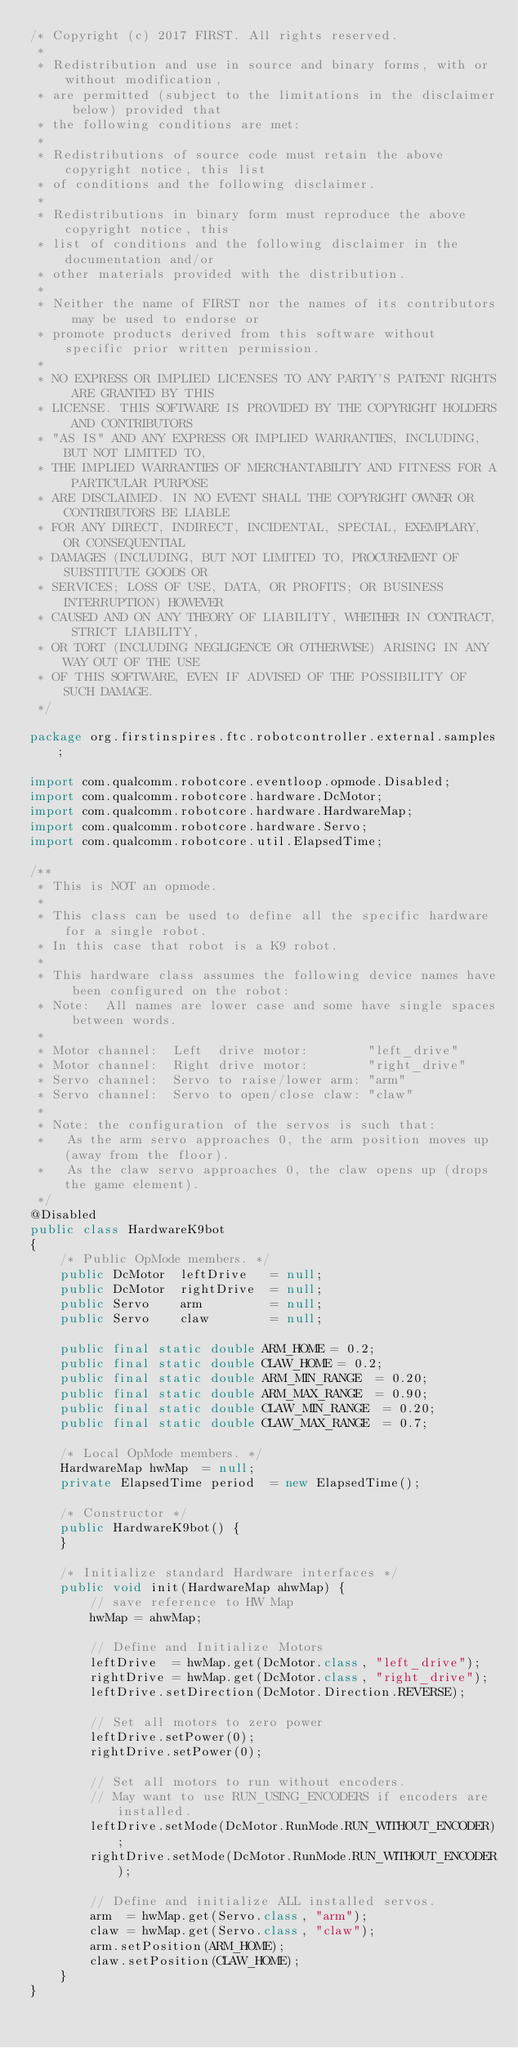Convert code to text. <code><loc_0><loc_0><loc_500><loc_500><_Java_>/* Copyright (c) 2017 FIRST. All rights reserved.
 *
 * Redistribution and use in source and binary forms, with or without modification,
 * are permitted (subject to the limitations in the disclaimer below) provided that
 * the following conditions are met:
 *
 * Redistributions of source code must retain the above copyright notice, this list
 * of conditions and the following disclaimer.
 *
 * Redistributions in binary form must reproduce the above copyright notice, this
 * list of conditions and the following disclaimer in the documentation and/or
 * other materials provided with the distribution.
 *
 * Neither the name of FIRST nor the names of its contributors may be used to endorse or
 * promote products derived from this software without specific prior written permission.
 *
 * NO EXPRESS OR IMPLIED LICENSES TO ANY PARTY'S PATENT RIGHTS ARE GRANTED BY THIS
 * LICENSE. THIS SOFTWARE IS PROVIDED BY THE COPYRIGHT HOLDERS AND CONTRIBUTORS
 * "AS IS" AND ANY EXPRESS OR IMPLIED WARRANTIES, INCLUDING, BUT NOT LIMITED TO,
 * THE IMPLIED WARRANTIES OF MERCHANTABILITY AND FITNESS FOR A PARTICULAR PURPOSE
 * ARE DISCLAIMED. IN NO EVENT SHALL THE COPYRIGHT OWNER OR CONTRIBUTORS BE LIABLE
 * FOR ANY DIRECT, INDIRECT, INCIDENTAL, SPECIAL, EXEMPLARY, OR CONSEQUENTIAL
 * DAMAGES (INCLUDING, BUT NOT LIMITED TO, PROCUREMENT OF SUBSTITUTE GOODS OR
 * SERVICES; LOSS OF USE, DATA, OR PROFITS; OR BUSINESS INTERRUPTION) HOWEVER
 * CAUSED AND ON ANY THEORY OF LIABILITY, WHETHER IN CONTRACT, STRICT LIABILITY,
 * OR TORT (INCLUDING NEGLIGENCE OR OTHERWISE) ARISING IN ANY WAY OUT OF THE USE
 * OF THIS SOFTWARE, EVEN IF ADVISED OF THE POSSIBILITY OF SUCH DAMAGE.
 */

package org.firstinspires.ftc.robotcontroller.external.samples;

import com.qualcomm.robotcore.eventloop.opmode.Disabled;
import com.qualcomm.robotcore.hardware.DcMotor;
import com.qualcomm.robotcore.hardware.HardwareMap;
import com.qualcomm.robotcore.hardware.Servo;
import com.qualcomm.robotcore.util.ElapsedTime;

/**
 * This is NOT an opmode.
 *
 * This class can be used to define all the specific hardware for a single robot.
 * In this case that robot is a K9 robot.
 *
 * This hardware class assumes the following device names have been configured on the robot:
 * Note:  All names are lower case and some have single spaces between words.
 *
 * Motor channel:  Left  drive motor:        "left_drive"
 * Motor channel:  Right drive motor:        "right_drive"
 * Servo channel:  Servo to raise/lower arm: "arm"
 * Servo channel:  Servo to open/close claw: "claw"
 *
 * Note: the configuration of the servos is such that:
 *   As the arm servo approaches 0, the arm position moves up (away from the floor).
 *   As the claw servo approaches 0, the claw opens up (drops the game element).
 */
@Disabled
public class HardwareK9bot
{
    /* Public OpMode members. */
    public DcMotor  leftDrive   = null;
    public DcMotor  rightDrive  = null;
    public Servo    arm         = null;
    public Servo    claw        = null;

    public final static double ARM_HOME = 0.2;
    public final static double CLAW_HOME = 0.2;
    public final static double ARM_MIN_RANGE  = 0.20;
    public final static double ARM_MAX_RANGE  = 0.90;
    public final static double CLAW_MIN_RANGE  = 0.20;
    public final static double CLAW_MAX_RANGE  = 0.7;

    /* Local OpMode members. */
    HardwareMap hwMap  = null;
    private ElapsedTime period  = new ElapsedTime();

    /* Constructor */
    public HardwareK9bot() {
    }

    /* Initialize standard Hardware interfaces */
    public void init(HardwareMap ahwMap) {
        // save reference to HW Map
        hwMap = ahwMap;

        // Define and Initialize Motors
        leftDrive  = hwMap.get(DcMotor.class, "left_drive");
        rightDrive = hwMap.get(DcMotor.class, "right_drive");
        leftDrive.setDirection(DcMotor.Direction.REVERSE);

        // Set all motors to zero power
        leftDrive.setPower(0);
        rightDrive.setPower(0);

        // Set all motors to run without encoders.
        // May want to use RUN_USING_ENCODERS if encoders are installed.
        leftDrive.setMode(DcMotor.RunMode.RUN_WITHOUT_ENCODER);
        rightDrive.setMode(DcMotor.RunMode.RUN_WITHOUT_ENCODER);

        // Define and initialize ALL installed servos.
        arm  = hwMap.get(Servo.class, "arm");
        claw = hwMap.get(Servo.class, "claw");
        arm.setPosition(ARM_HOME);
        claw.setPosition(CLAW_HOME);
    }
}
</code> 